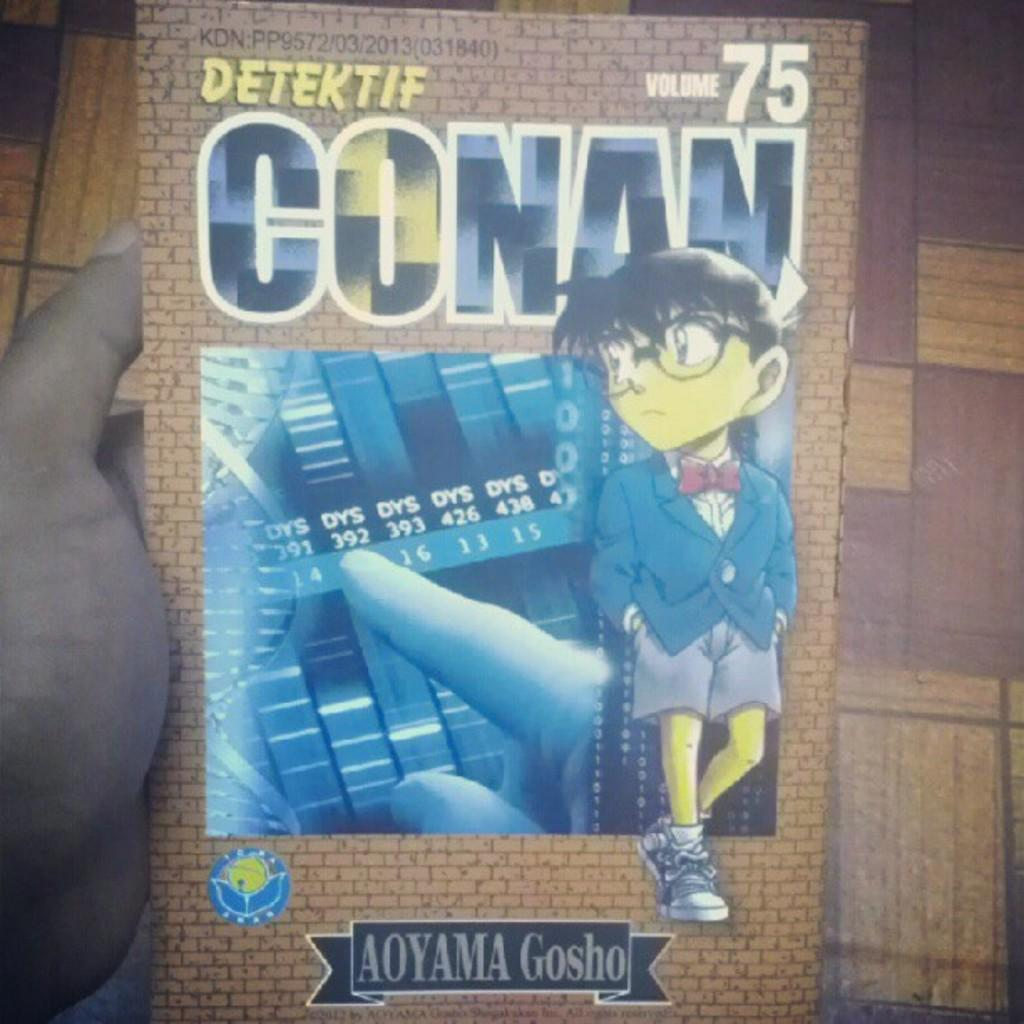<image>
Create a compact narrative representing the image presented. Anime magazine with the words volume 75 on the top right 